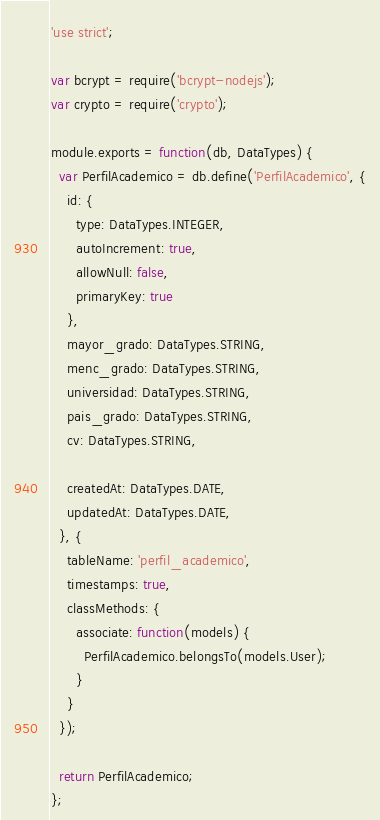Convert code to text. <code><loc_0><loc_0><loc_500><loc_500><_JavaScript_>'use strict';

var bcrypt = require('bcrypt-nodejs');
var crypto = require('crypto');

module.exports = function(db, DataTypes) {
  var PerfilAcademico = db.define('PerfilAcademico', {
    id: {
      type: DataTypes.INTEGER,
      autoIncrement: true,
      allowNull: false,
      primaryKey: true
    },
    mayor_grado: DataTypes.STRING,
    menc_grado: DataTypes.STRING,
    universidad: DataTypes.STRING,
    pais_grado: DataTypes.STRING,
    cv: DataTypes.STRING,

    createdAt: DataTypes.DATE,
    updatedAt: DataTypes.DATE,
  }, {
    tableName: 'perfil_academico',
    timestamps: true,
    classMethods: {
      associate: function(models) {
        PerfilAcademico.belongsTo(models.User);
      }
    }
  });

  return PerfilAcademico;
};</code> 